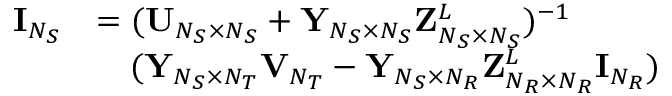Convert formula to latex. <formula><loc_0><loc_0><loc_500><loc_500>\begin{array} { r l } { { I } _ { N _ { S } } } & { = ( { U } _ { N _ { S } \times N _ { S } } + { Y } _ { N _ { S } \times N _ { S } } { Z } _ { N _ { S } \times N _ { S } } ^ { L } ) ^ { - 1 } } \\ & { \quad ( { Y } _ { N _ { S } \times N _ { T } } { V } _ { N _ { T } } - { Y } _ { N _ { S } \times N _ { R } } { Z } _ { N _ { R } \times N _ { R } } ^ { L } { I } _ { N _ { R } } ) } \end{array}</formula> 